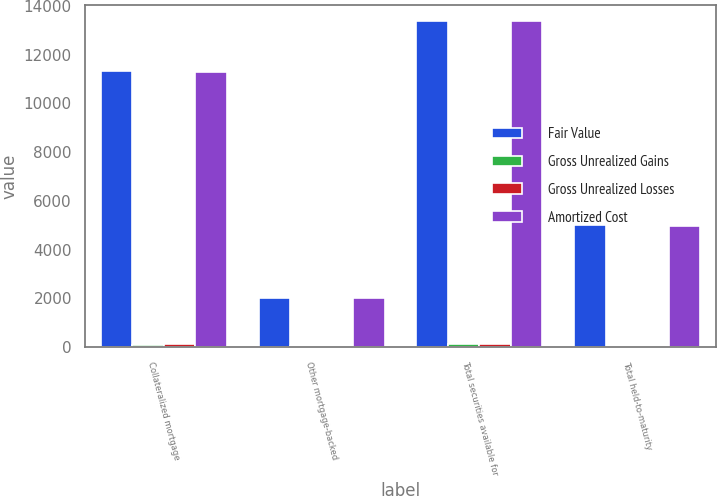<chart> <loc_0><loc_0><loc_500><loc_500><stacked_bar_chart><ecel><fcel>Collateralized mortgage<fcel>Other mortgage-backed<fcel>Total securities available for<fcel>Total held-to-maturity<nl><fcel>Fair Value<fcel>11310<fcel>2004<fcel>13365<fcel>5015<nl><fcel>Gross Unrealized Gains<fcel>96<fcel>32<fcel>132<fcel>16<nl><fcel>Gross Unrealized Losses<fcel>136<fcel>1<fcel>137<fcel>57<nl><fcel>Amortized Cost<fcel>11270<fcel>2035<fcel>13360<fcel>4974<nl></chart> 